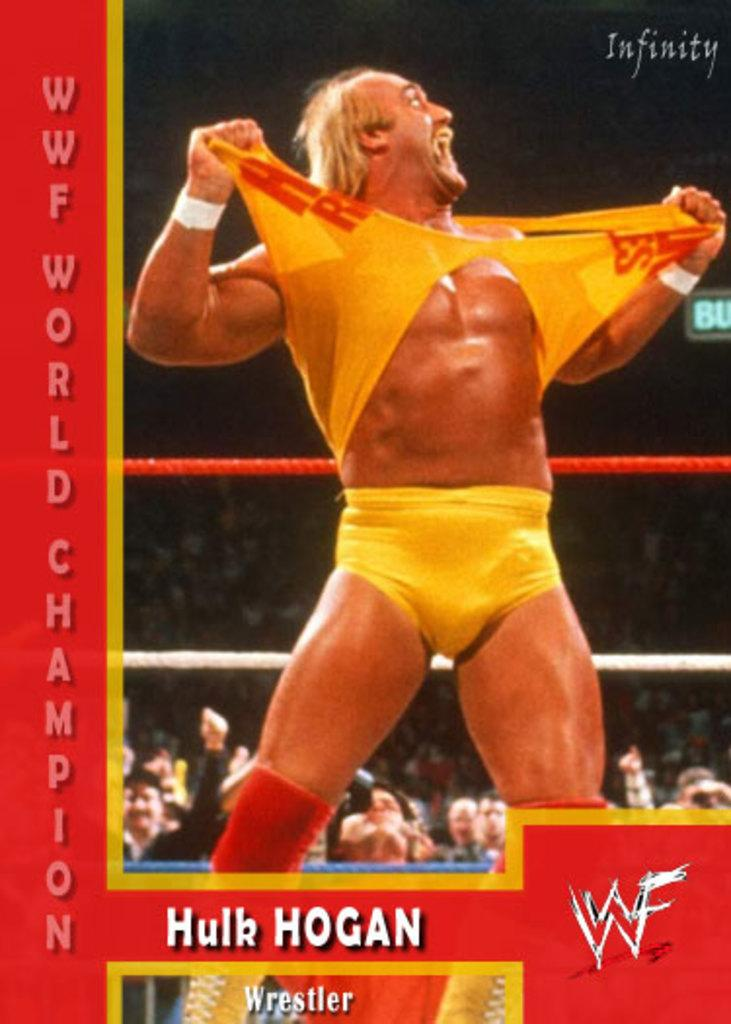<image>
Give a short and clear explanation of the subsequent image. WWF world champion Hulk Hogan is pictured ripping his shirt. 